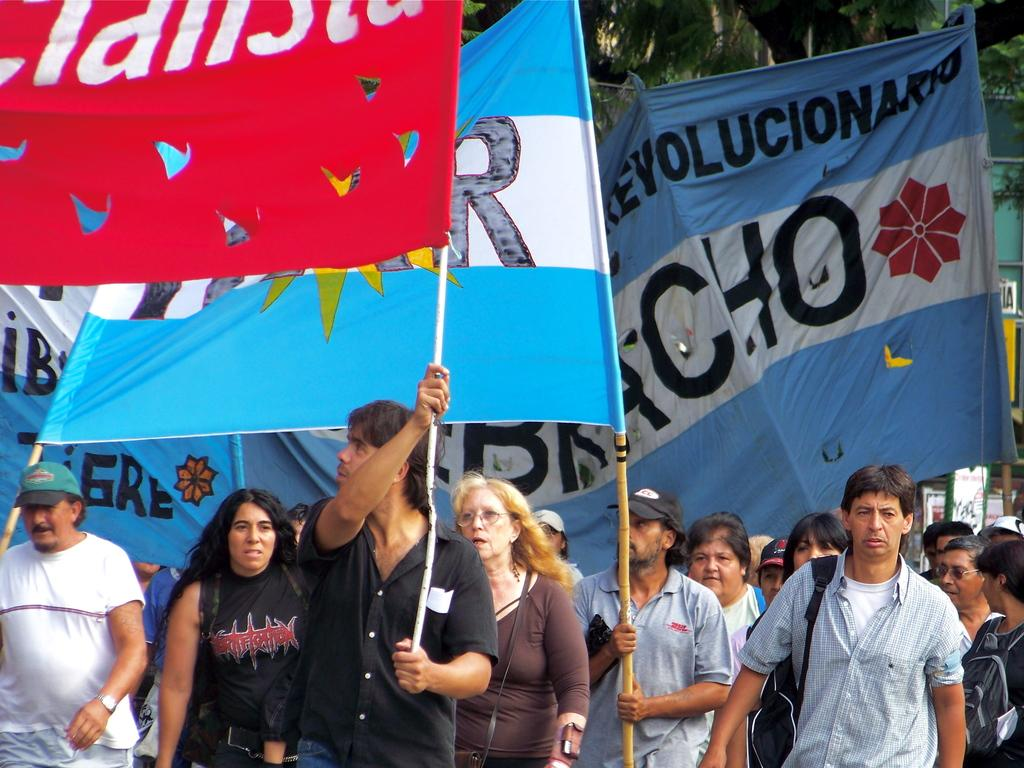<image>
Describe the image concisely. People marching with flag one has evolucion on it. 